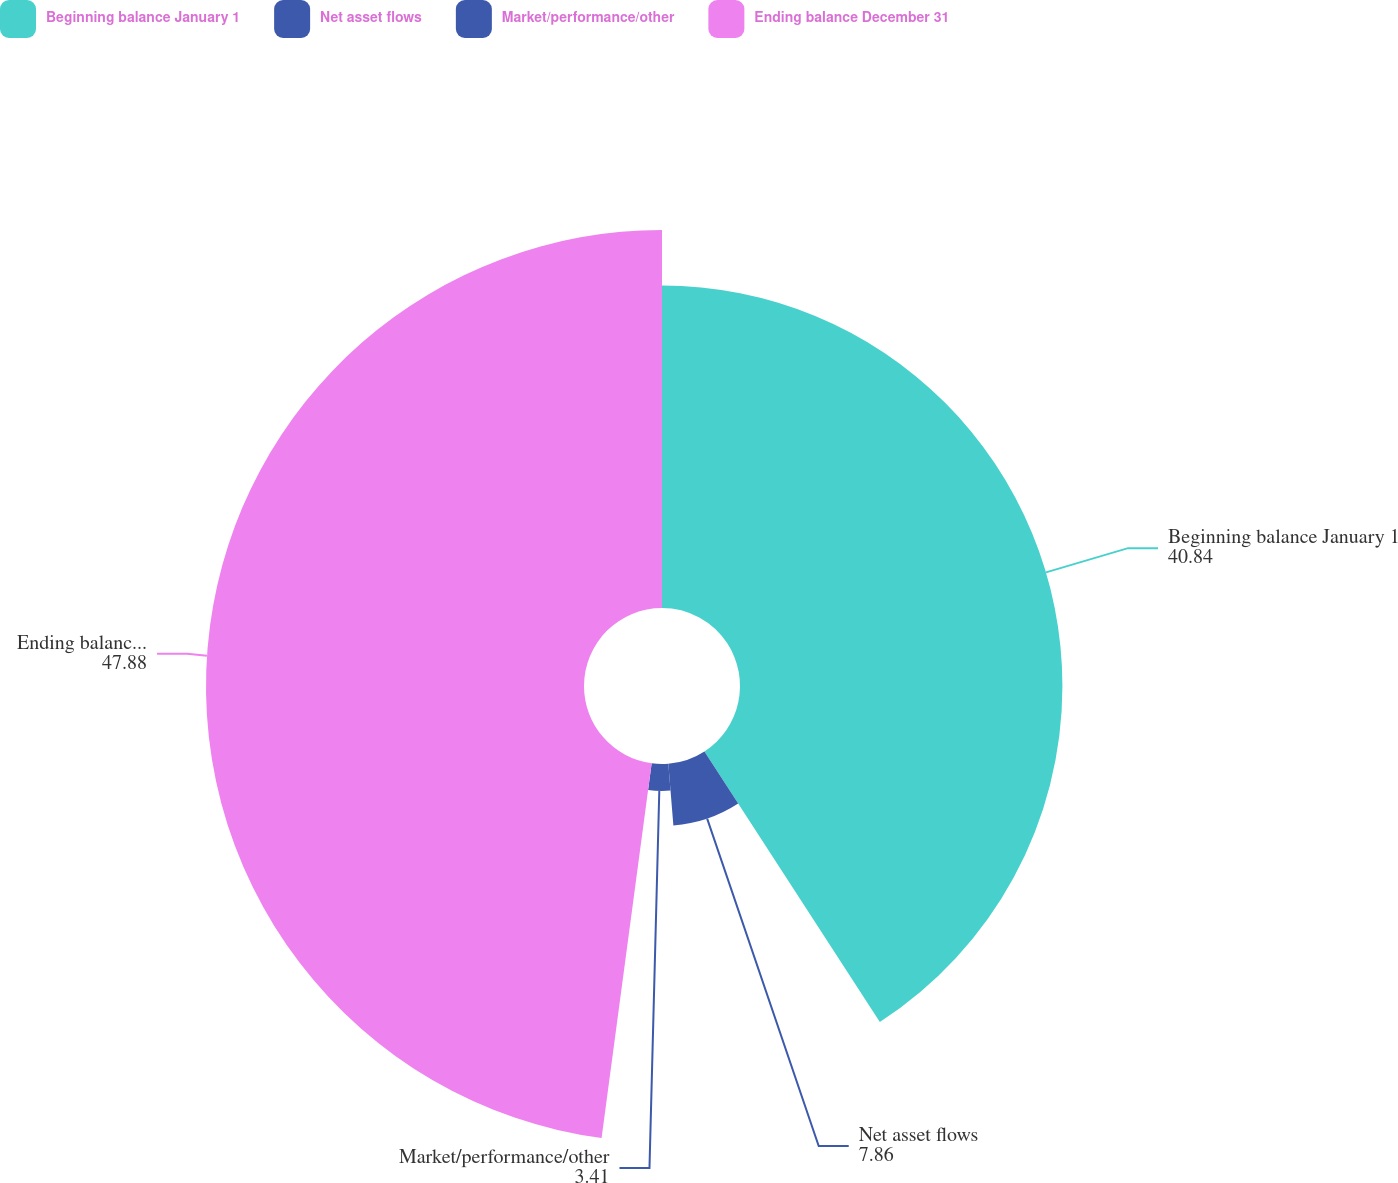Convert chart to OTSL. <chart><loc_0><loc_0><loc_500><loc_500><pie_chart><fcel>Beginning balance January 1<fcel>Net asset flows<fcel>Market/performance/other<fcel>Ending balance December 31<nl><fcel>40.84%<fcel>7.86%<fcel>3.41%<fcel>47.88%<nl></chart> 